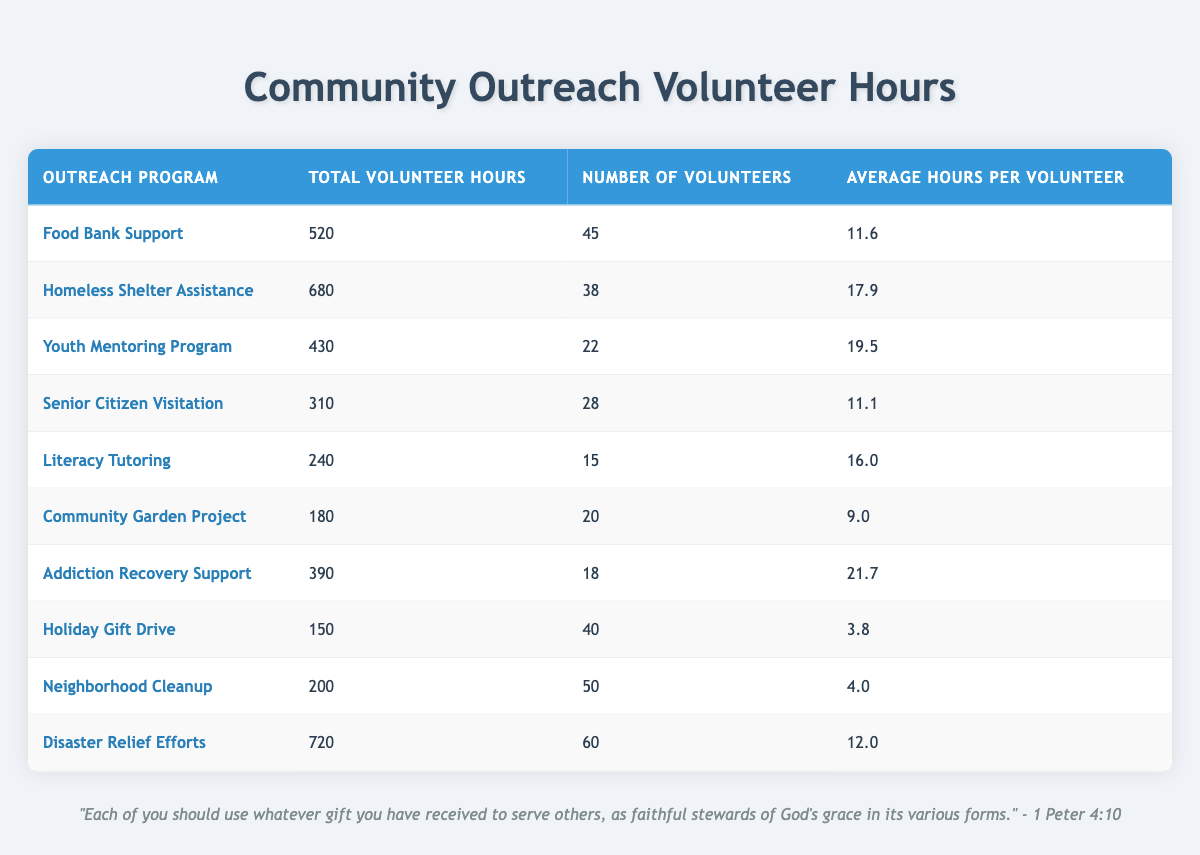What is the total volunteer hours for the 'Food Bank Support' program? According to the table, the specific entry for the 'Food Bank Support' program shows that the total volunteer hours are 520.
Answer: 520 How many volunteers participated in the 'Addiction Recovery Support' program? The table lists the number of volunteers for the 'Addiction Recovery Support' program as 18.
Answer: 18 Which program had the highest average hours per volunteer? By reviewing the average hours per volunteer, the 'Addiction Recovery Support' program has the highest average at 21.7 hours among all programs listed.
Answer: Addiction Recovery Support Is the total volunteer hours for 'Neighborhood Cleanup' more than 200? The table indicates that the total volunteer hours for 'Neighborhood Cleanup' is exactly 200, so it is not greater than that amount.
Answer: No What is the sum of total volunteer hours for both the 'Literacy Tutoring' and 'Community Garden Project'? To find the total, we add the volunteer hours for both programs: 240 (Literacy Tutoring) + 180 (Community Garden Project) = 420.
Answer: 420 What is the average number of volunteers across all programs? We sum the number of volunteers from each program (45 + 38 + 22 + 28 + 15 + 20 + 18 + 40 + 50 + 60 = 348), then divide by the number of programs (10), giving us an average of 34.8 volunteers per program.
Answer: 34.8 Did more than half of the programs have an average hours per volunteer greater than 15? There are six programs with average hours greater than 15 (Homeless Shelter Assistance, Youth Mentoring Program, Literacy Tutoring, and Addiction Recovery Support). Since there are 10 programs, and 6 is more than half, the answer is yes.
Answer: Yes What is the difference in total volunteer hours between 'Disaster Relief Efforts' and 'Holiday Gift Drive'? The total for 'Disaster Relief Efforts' is 720, and for 'Holiday Gift Drive,' it is 150. The difference is calculated as 720 - 150 = 570.
Answer: 570 Which outreach program had the least number of total volunteer hours? Looking through the table, the program with the least total hours is 'Holiday Gift Drive' at 150 hours.
Answer: Holiday Gift Drive 